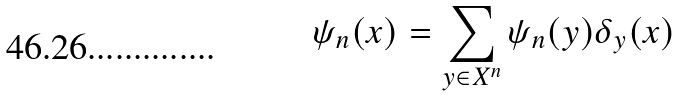<formula> <loc_0><loc_0><loc_500><loc_500>\psi _ { n } ( x ) = \sum _ { y \in X ^ { n } } \psi _ { n } ( y ) \delta _ { y } ( x )</formula> 